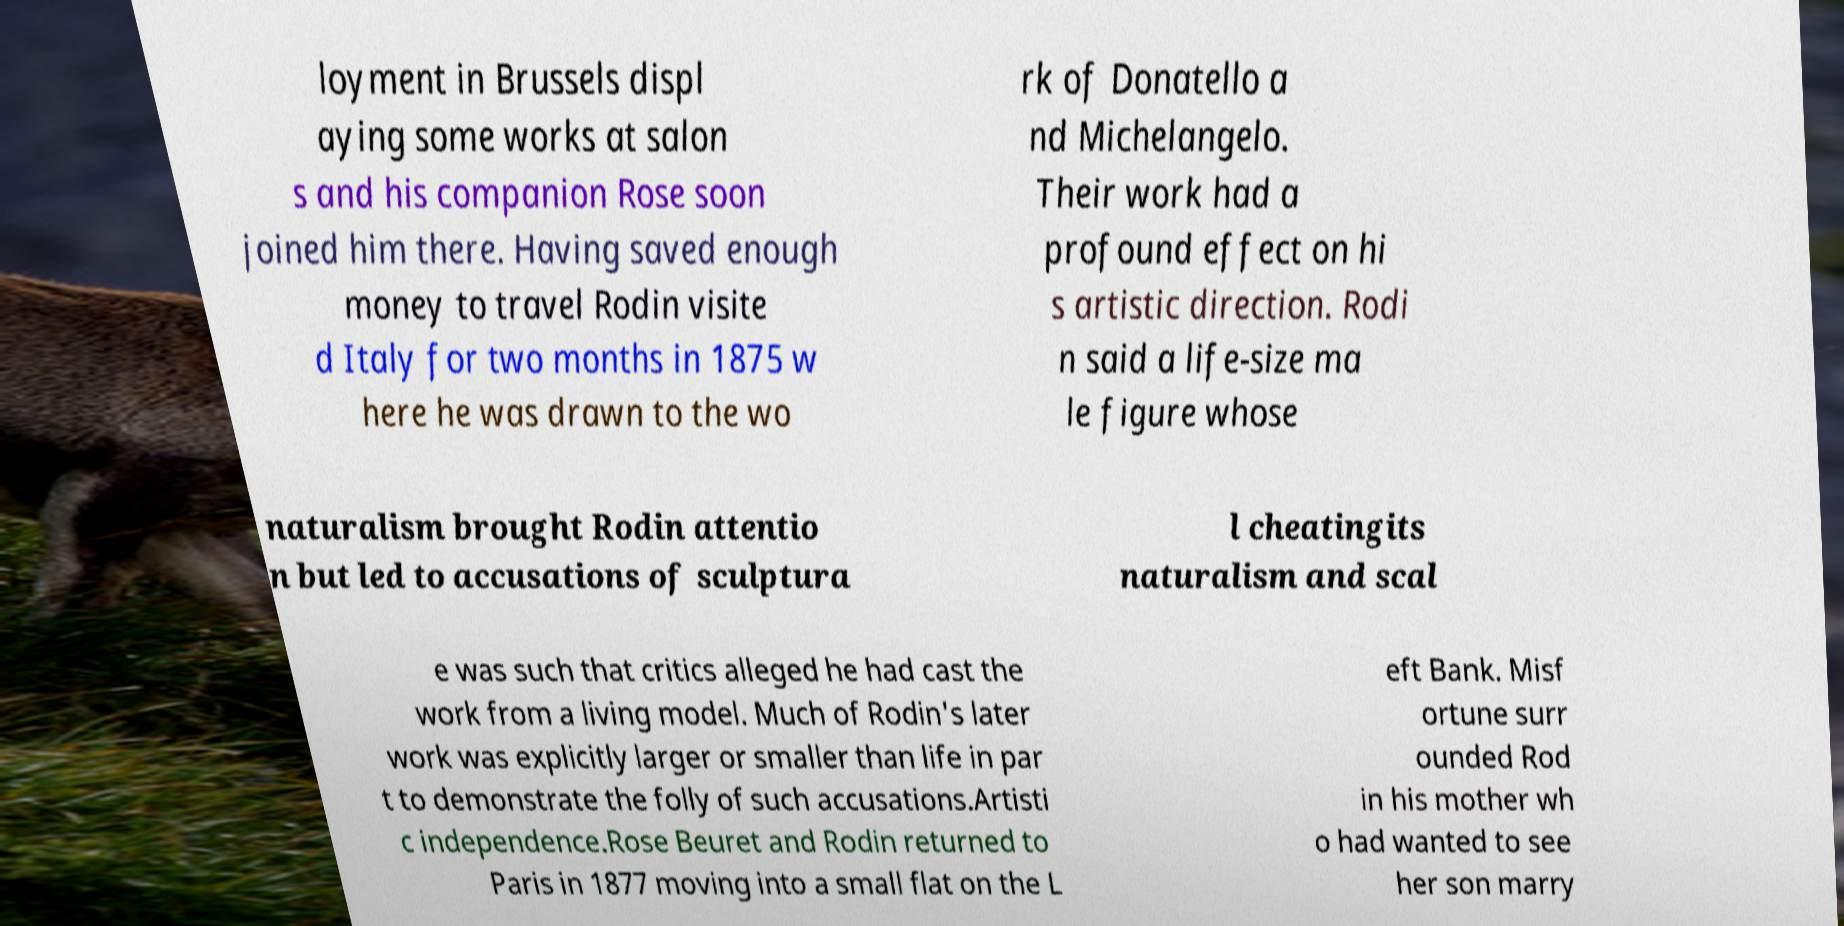There's text embedded in this image that I need extracted. Can you transcribe it verbatim? loyment in Brussels displ aying some works at salon s and his companion Rose soon joined him there. Having saved enough money to travel Rodin visite d Italy for two months in 1875 w here he was drawn to the wo rk of Donatello a nd Michelangelo. Their work had a profound effect on hi s artistic direction. Rodi n said a life-size ma le figure whose naturalism brought Rodin attentio n but led to accusations of sculptura l cheatingits naturalism and scal e was such that critics alleged he had cast the work from a living model. Much of Rodin's later work was explicitly larger or smaller than life in par t to demonstrate the folly of such accusations.Artisti c independence.Rose Beuret and Rodin returned to Paris in 1877 moving into a small flat on the L eft Bank. Misf ortune surr ounded Rod in his mother wh o had wanted to see her son marry 